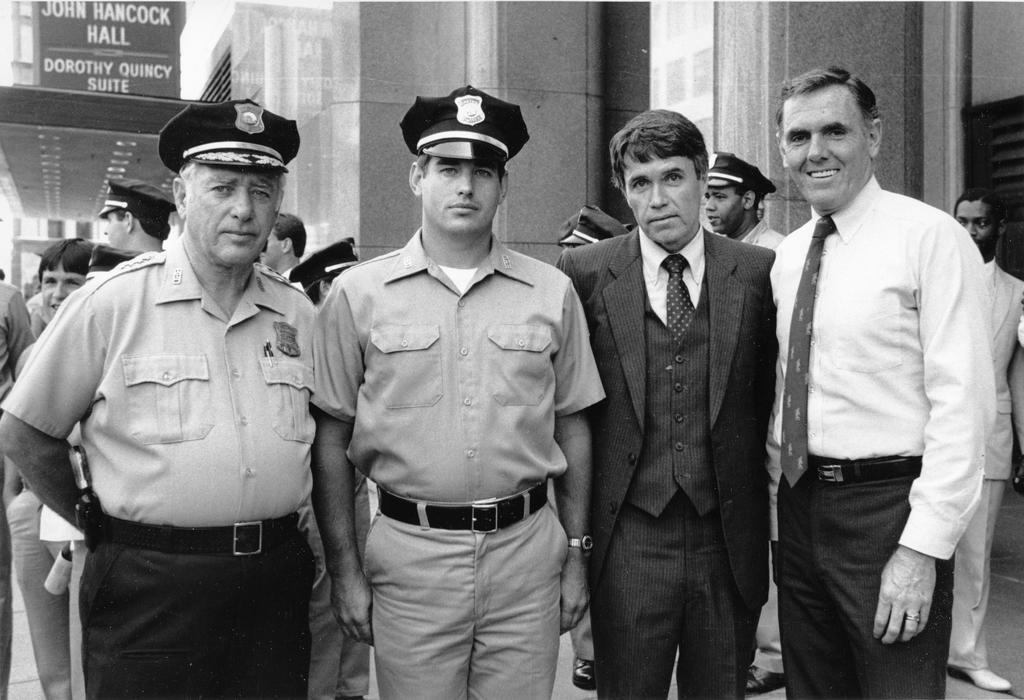What is happening in the middle of the image? There are people standing in the middle of the image. How are the people in the middle feeling? The people in the middle are smiling. Are there any other people in the image? Yes, there are people standing behind the group in the middle. What can be seen in the distance behind the people? There are buildings visible in the background. What type of brass instrument is being played by the people in the image? There is no brass instrument present in the image; the people are simply standing and smiling. 